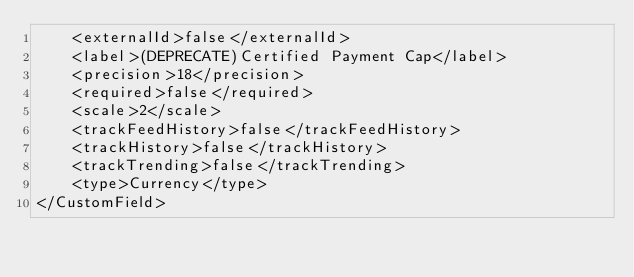<code> <loc_0><loc_0><loc_500><loc_500><_XML_>    <externalId>false</externalId>
    <label>(DEPRECATE)Certified Payment Cap</label>
    <precision>18</precision>
    <required>false</required>
    <scale>2</scale>
    <trackFeedHistory>false</trackFeedHistory>
    <trackHistory>false</trackHistory>
    <trackTrending>false</trackTrending>
    <type>Currency</type>
</CustomField>
</code> 